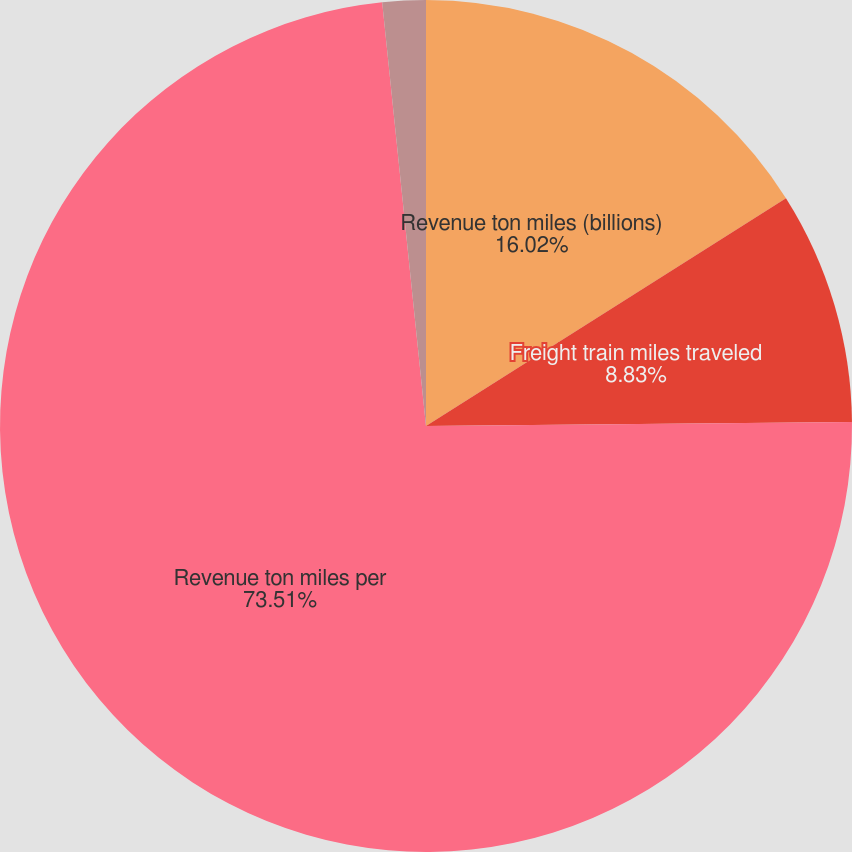Convert chart to OTSL. <chart><loc_0><loc_0><loc_500><loc_500><pie_chart><fcel>Revenue ton miles (billions)<fcel>Freight train miles traveled<fcel>Revenue ton miles per<fcel>Ratio of railway operating<nl><fcel>16.02%<fcel>8.83%<fcel>73.51%<fcel>1.64%<nl></chart> 